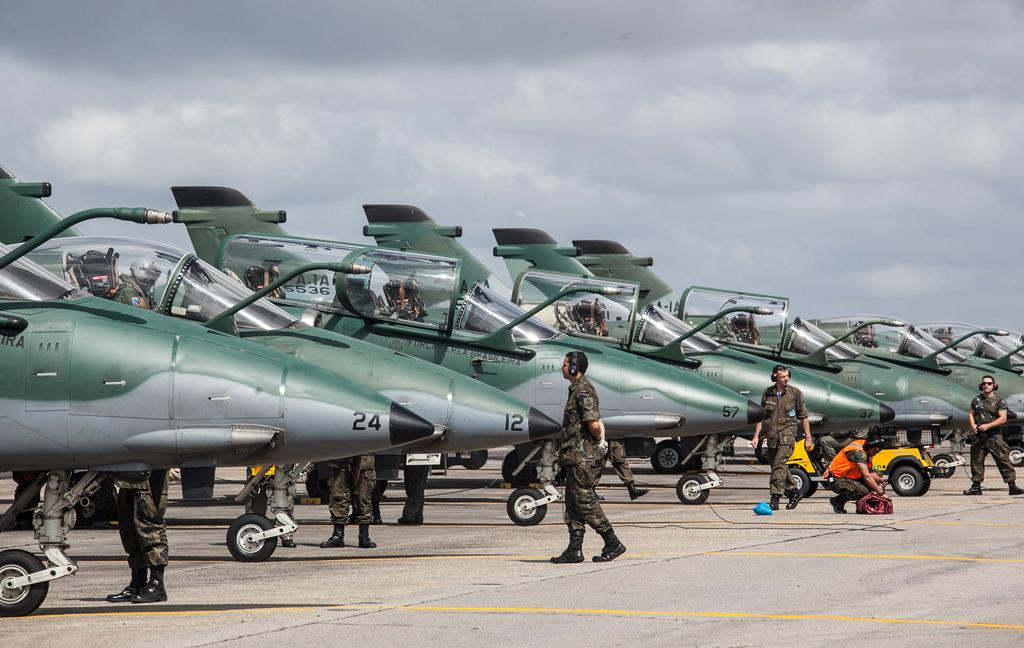What is the main subject of the image? The main subject of the image is airplanes. Are there any other vehicles or objects in the image? Yes, there is a vehicle in the image. What is happening on the ground in the image? There are people on the road in the image. What can be seen in the background of the image? Sky is visible in the background of the image, and clouds are present in the sky. What type of shoe is the grandmother wearing in the image? There is no grandmother or shoe present in the image. 